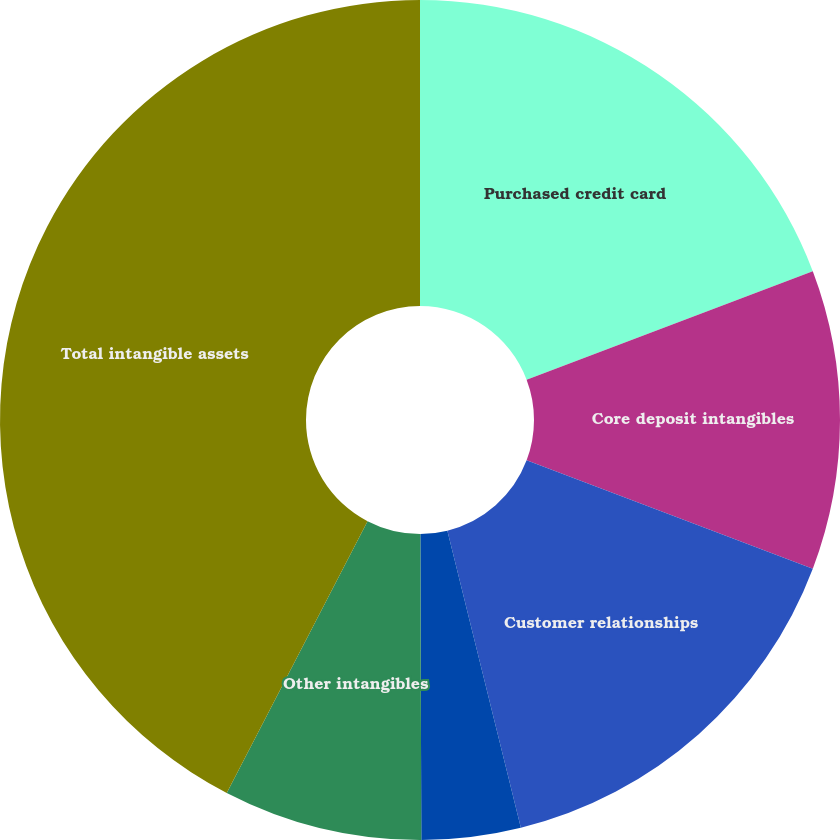<chart> <loc_0><loc_0><loc_500><loc_500><pie_chart><fcel>Purchased credit card<fcel>Core deposit intangibles<fcel>Customer relationships<fcel>Affinity relationships<fcel>Other intangibles<fcel>Total intangible assets<nl><fcel>19.24%<fcel>11.52%<fcel>15.38%<fcel>3.81%<fcel>7.66%<fcel>42.39%<nl></chart> 